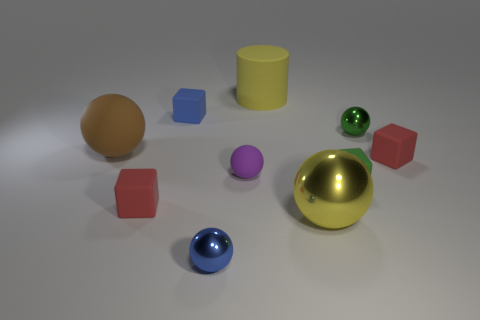Do the big cylinder and the large shiny sphere have the same color?
Offer a very short reply. Yes. How many red objects have the same shape as the tiny blue matte thing?
Ensure brevity in your answer.  2. What number of objects are small rubber blocks that are behind the large brown matte thing or matte balls in front of the tiny blue cube?
Offer a very short reply. 3. There is a large sphere that is right of the tiny metallic sphere in front of the yellow thing on the right side of the large matte cylinder; what is its material?
Provide a short and direct response. Metal. There is a large metal object to the right of the small blue rubber thing; does it have the same color as the large matte cylinder?
Your response must be concise. Yes. There is a ball that is on the right side of the purple rubber sphere and in front of the small green metal thing; what is its material?
Offer a terse response. Metal. Is there a red matte thing of the same size as the green block?
Provide a short and direct response. Yes. What number of purple rubber things are there?
Provide a short and direct response. 1. What number of yellow matte cylinders are behind the yellow ball?
Your answer should be compact. 1. Do the large brown thing and the yellow ball have the same material?
Offer a very short reply. No. 